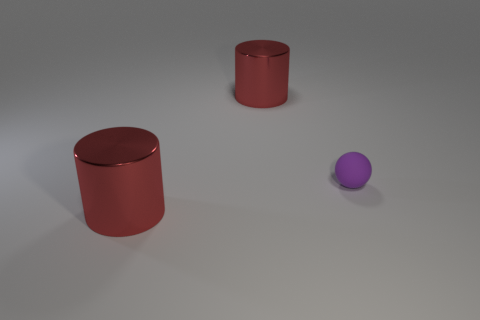There is a big cylinder in front of the small ball; does it have the same color as the large cylinder that is behind the ball?
Provide a succinct answer. Yes. Is there any other thing that has the same size as the rubber sphere?
Offer a very short reply. No. Is there anything else that has the same shape as the small matte object?
Ensure brevity in your answer.  No. There is a big cylinder that is on the left side of the shiny thing behind the small matte object; is there a tiny ball that is in front of it?
Your answer should be compact. No. What size is the red shiny cylinder that is behind the big metallic cylinder that is in front of the metal object behind the tiny purple object?
Give a very brief answer. Large. How many purple rubber objects are on the right side of the big red cylinder that is behind the small object?
Offer a terse response. 1. What is the material of the ball that is right of the red metallic cylinder that is behind the tiny purple matte object?
Give a very brief answer. Rubber. Is the size of the red cylinder behind the purple ball the same as the matte sphere?
Your response must be concise. No. How many rubber things are either large red objects or purple balls?
Give a very brief answer. 1. There is a matte thing; what shape is it?
Offer a very short reply. Sphere. 